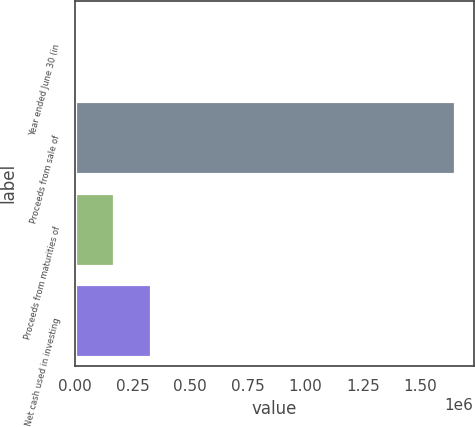Convert chart to OTSL. <chart><loc_0><loc_0><loc_500><loc_500><bar_chart><fcel>Year ended June 30 (in<fcel>Proceeds from sale of<fcel>Proceeds from maturities of<fcel>Net cash used in investing<nl><fcel>2004<fcel>1.64956e+06<fcel>166759<fcel>331515<nl></chart> 